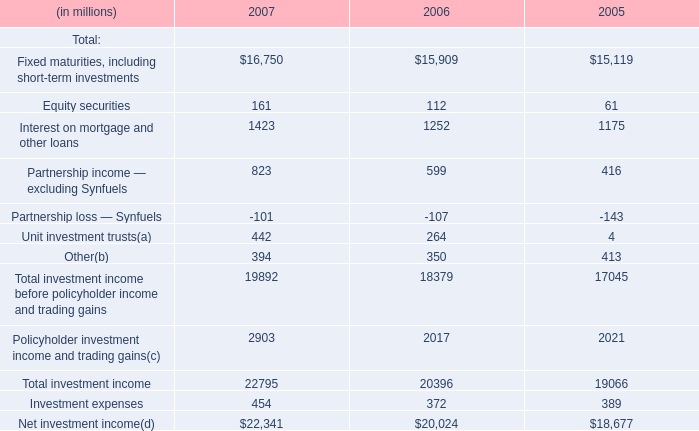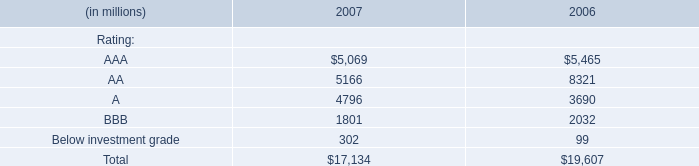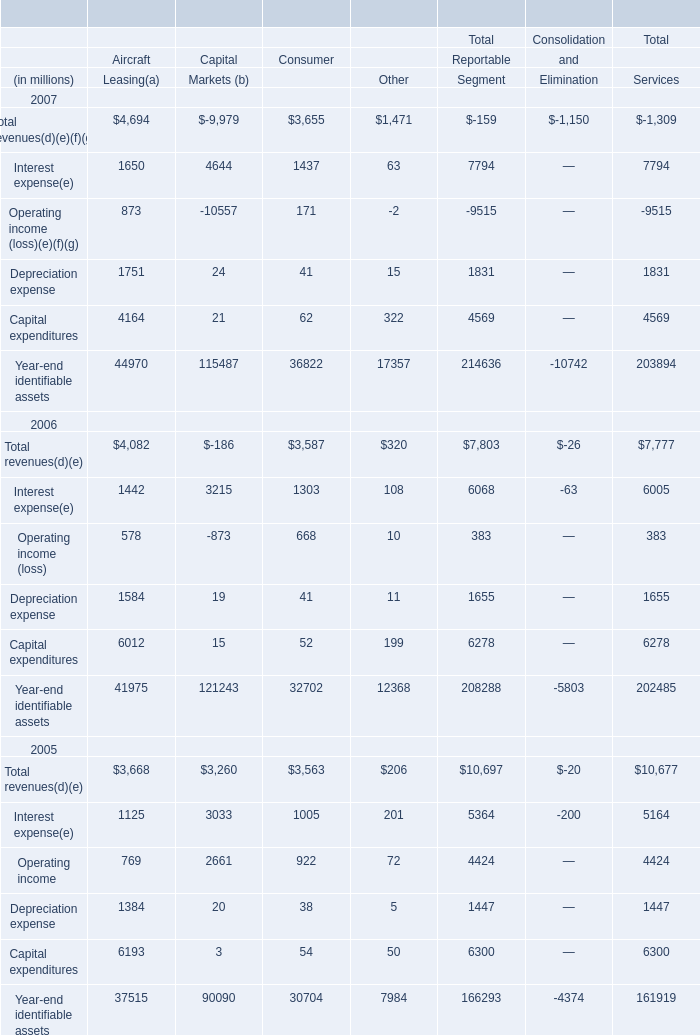In what year is Operating income of capital markets positive? (in year) 
Answer: 2005. 